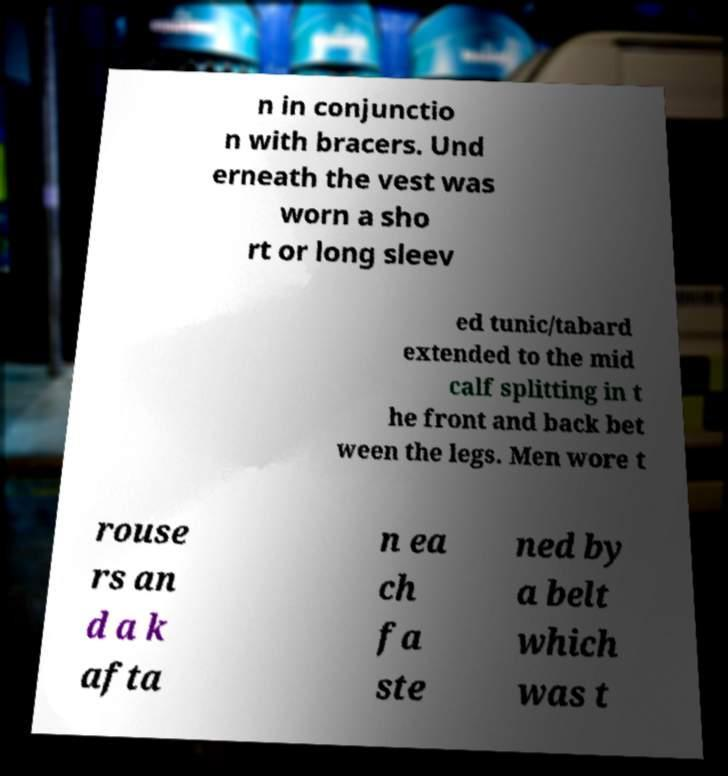There's text embedded in this image that I need extracted. Can you transcribe it verbatim? n in conjunctio n with bracers. Und erneath the vest was worn a sho rt or long sleev ed tunic/tabard extended to the mid calf splitting in t he front and back bet ween the legs. Men wore t rouse rs an d a k afta n ea ch fa ste ned by a belt which was t 